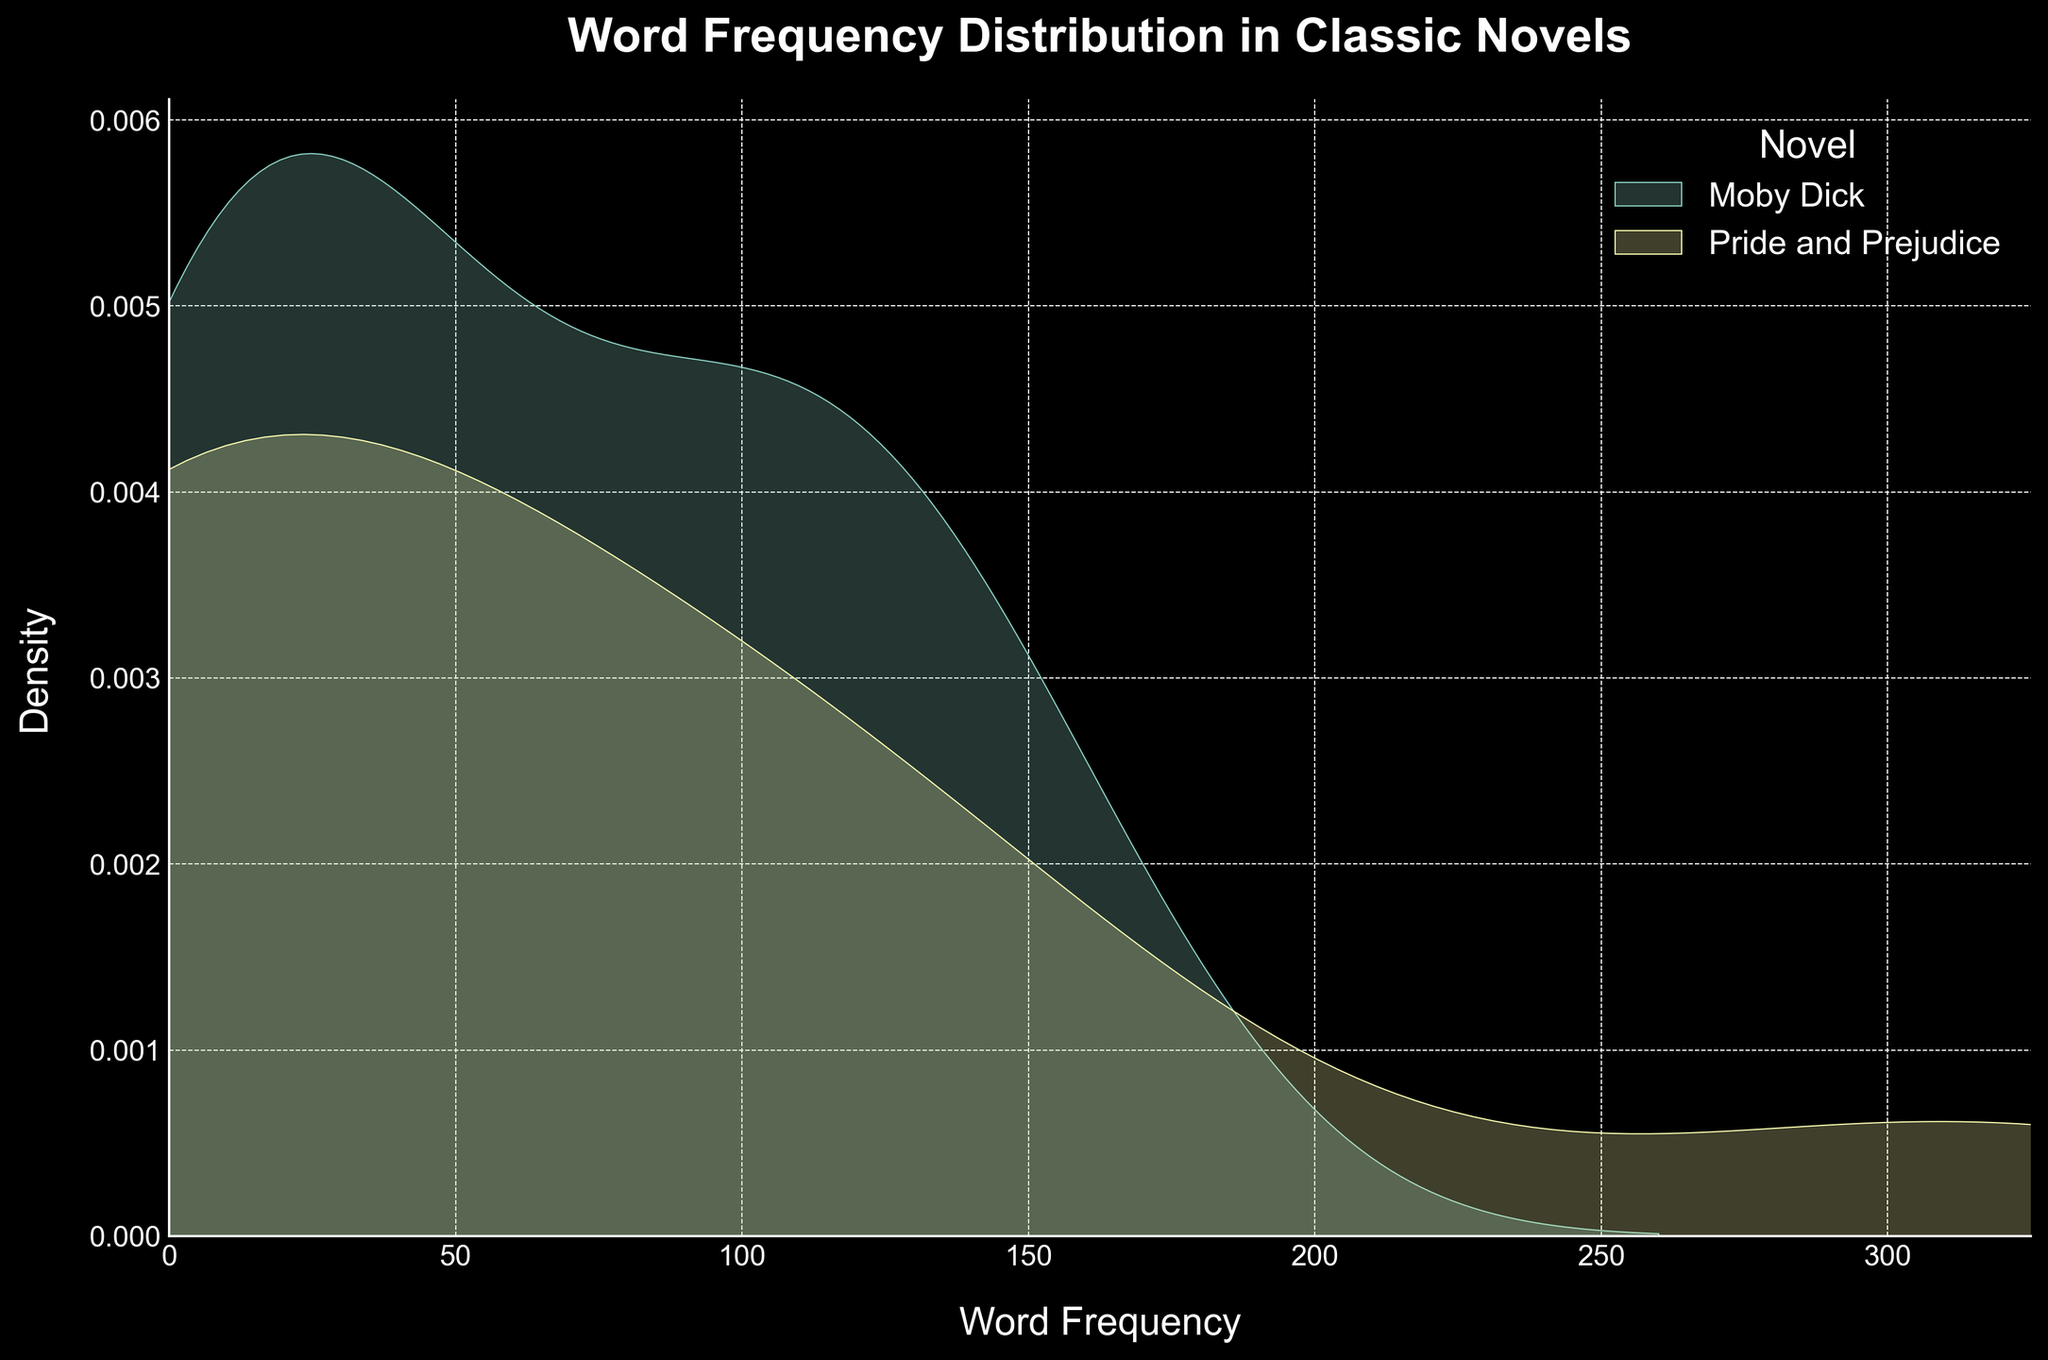What is the title of the plot? The title of the plot is written at the top of the figure, usually in a larger font size and bolded for emphasis.
Answer: Word Frequency Distribution in Classic Novels What novels are being compared in the plot? The legend on the plot lists the novels being compared by their titles, each associated with a color.
Answer: Moby Dick and Pride and Prejudice What does the x-axis represent? The x-axis label at the bottom of the plot indicates what the horizontal axis measures. In this case, it is labeled 'Word Frequency'.
Answer: Word Frequency Which book shows a higher density for high-frequency words? The density of word frequency can be seen by the peaks in the density plot. A higher peak represents a greater density.
Answer: Moby Dick Between "Moby Dick" and "Pride and Prejudice", which novel has more instances of words with frequency less than 10? The area under the curve to the left of the 10 mark on the x-axis represents the density of words with a frequency less than 10. By observing and comparing the shaded regions, you determine which area is larger.
Answer: Pride and Prejudice What does the y-axis represent? The y-axis label indicates what the vertical axis measures. Here, it is labeled 'Density'.
Answer: Density Are there any words that appear more than 300 times in a single novel? A word appearing more than 300 times would be located on the far right of the x-axis and would show a density peak if present.
Answer: Yes Which novel has a higher peak density at around a frequency of 150? By observing the peaks around the frequency value of 150 on the x-axis, you can see which novel's density plot shows a higher elevation.
Answer: Moby Dick Do both novels show density for words with a frequency of up to 100? By looking at the distribution spread along the x-axis up to the 100 mark, you can confirm the presence of density plots for both novels in this range.
Answer: Yes How many words in "Pride and Prejudice" have a frequency above 50? Words with a frequency above 50 are denoted by density peaks on the right side of the 50 mark on the x-axis. You need to examine the plot to count these properly.
Answer: Four 